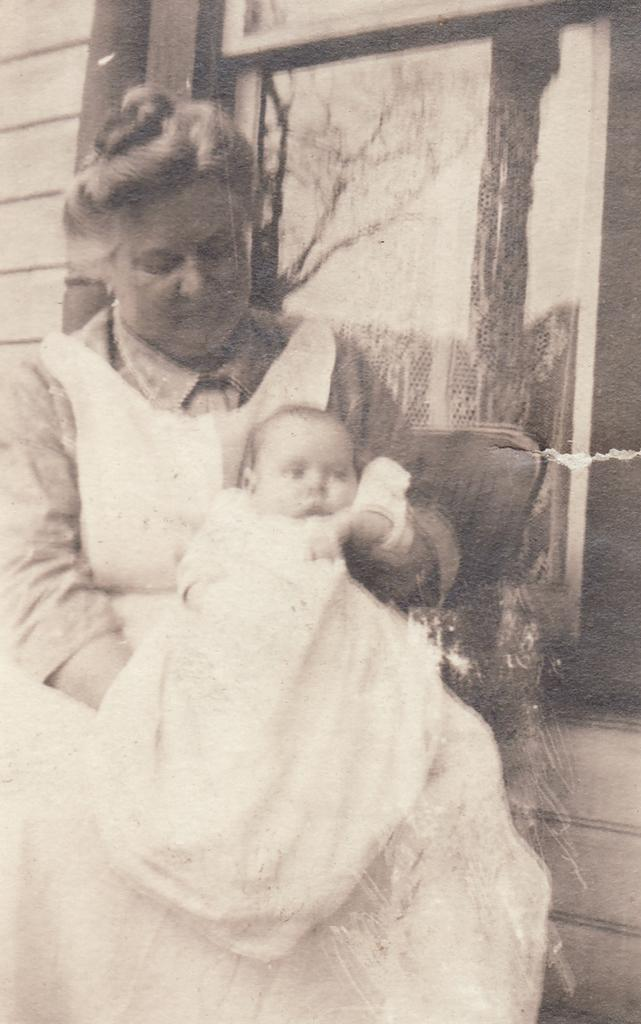What is the main subject of the image? There is a photo in the image. What can be seen in the photo? The photo contains a woman holding a baby. What else is visible in the image besides the photo? There is a wall visible in the image. What type of machine is being used by the woman to hold the baby in the image? There is no machine present in the image; the woman is holding the baby with her arms. What type of cushion is being used by the baby in the image? There is no cushion visible in the image; the baby is being held by the woman. 